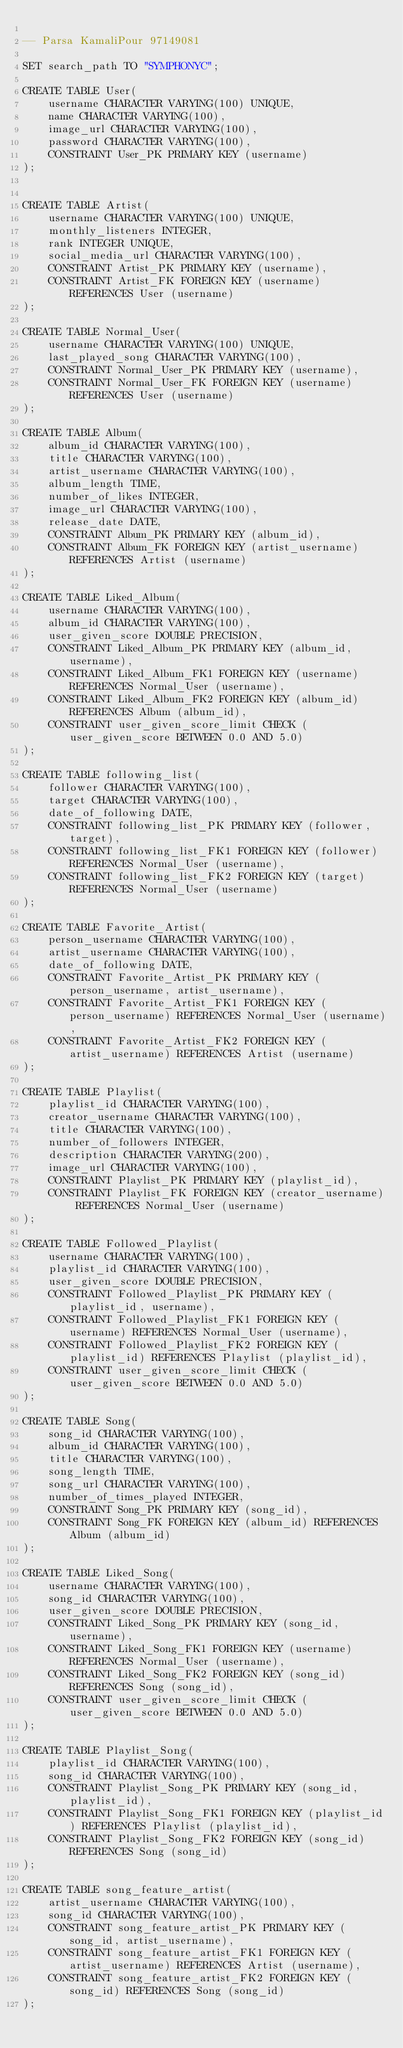<code> <loc_0><loc_0><loc_500><loc_500><_SQL_>
-- Parsa KamaliPour 97149081

SET search_path TO "SYMPHONYC";

CREATE TABLE User(
	username CHARACTER VARYING(100) UNIQUE,
	name CHARACTER VARYING(100),
	image_url CHARACTER VARYING(100),
	password CHARACTER VARYING(100),
	CONSTRAINT User_PK PRIMARY KEY (username)
);


CREATE TABLE Artist(
	username CHARACTER VARYING(100) UNIQUE,
	monthly_listeners INTEGER,
	rank INTEGER UNIQUE,
	social_media_url CHARACTER VARYING(100),
	CONSTRAINT Artist_PK PRIMARY KEY (username),
	CONSTRAINT Artist_FK FOREIGN KEY (username) REFERENCES User (username)
);

CREATE TABLE Normal_User(
	username CHARACTER VARYING(100) UNIQUE,
	last_played_song CHARACTER VARYING(100),
	CONSTRAINT Normal_User_PK PRIMARY KEY (username),
	CONSTRAINT Normal_User_FK FOREIGN KEY (username) REFERENCES User (username)
);

CREATE TABLE Album(
	album_id CHARACTER VARYING(100),
	title CHARACTER VARYING(100),
	artist_username CHARACTER VARYING(100),
	album_length TIME,
	number_of_likes INTEGER,
	image_url CHARACTER VARYING(100),
	release_date DATE,
	CONSTRAINT Album_PK PRIMARY KEY (album_id),
	CONSTRAINT Album_FK FOREIGN KEY (artist_username) REFERENCES Artist (username)
);

CREATE TABLE Liked_Album(
	username CHARACTER VARYING(100),
	album_id CHARACTER VARYING(100),
	user_given_score DOUBLE PRECISION,
	CONSTRAINT Liked_Album_PK PRIMARY KEY (album_id, username),
	CONSTRAINT Liked_Album_FK1 FOREIGN KEY (username) REFERENCES Normal_User (username),
	CONSTRAINT Liked_Album_FK2 FOREIGN KEY (album_id) REFERENCES Album (album_id),
	CONSTRAINT user_given_score_limit CHECK (user_given_score BETWEEN 0.0 AND 5.0)
);

CREATE TABLE following_list(
	follower CHARACTER VARYING(100),
	target CHARACTER VARYING(100),
	date_of_following DATE,
	CONSTRAINT following_list_PK PRIMARY KEY (follower, target),
	CONSTRAINT following_list_FK1 FOREIGN KEY (follower) REFERENCES Normal_User (username),
	CONSTRAINT following_list_FK2 FOREIGN KEY (target) REFERENCES Normal_User (username)
);

CREATE TABLE Favorite_Artist(
	person_username CHARACTER VARYING(100),
	artist_username CHARACTER VARYING(100),
	date_of_following DATE,
	CONSTRAINT Favorite_Artist_PK PRIMARY KEY (person_username, artist_username),
	CONSTRAINT Favorite_Artist_FK1 FOREIGN KEY (person_username) REFERENCES Normal_User (username),
	CONSTRAINT Favorite_Artist_FK2 FOREIGN KEY (artist_username) REFERENCES Artist (username)
);

CREATE TABLE Playlist(
	playlist_id CHARACTER VARYING(100),
	creator_username CHARACTER VARYING(100),
	title CHARACTER VARYING(100),
	number_of_followers INTEGER,
	description CHARACTER VARYING(200),
	image_url CHARACTER VARYING(100),
	CONSTRAINT Playlist_PK PRIMARY KEY (playlist_id),
	CONSTRAINT Playlist_FK FOREIGN KEY (creator_username) REFERENCES Normal_User (username)
);

CREATE TABLE Followed_Playlist(
	username CHARACTER VARYING(100),
	playlist_id CHARACTER VARYING(100),
	user_given_score DOUBLE PRECISION,
	CONSTRAINT Followed_Playlist_PK PRIMARY KEY (playlist_id, username),
	CONSTRAINT Followed_Playlist_FK1 FOREIGN KEY (username) REFERENCES Normal_User (username),
	CONSTRAINT Followed_Playlist_FK2 FOREIGN KEY (playlist_id) REFERENCES Playlist (playlist_id),
	CONSTRAINT user_given_score_limit CHECK (user_given_score BETWEEN 0.0 AND 5.0)
);

CREATE TABLE Song(
	song_id CHARACTER VARYING(100),
	album_id CHARACTER VARYING(100),
	title CHARACTER VARYING(100),
	song_length TIME,
	song_url CHARACTER VARYING(100),
	number_of_times_played INTEGER,
	CONSTRAINT Song_PK PRIMARY KEY (song_id),
	CONSTRAINT Song_FK FOREIGN KEY (album_id) REFERENCES Album (album_id)
);

CREATE TABLE Liked_Song(
	username CHARACTER VARYING(100),
	song_id CHARACTER VARYING(100),
	user_given_score DOUBLE PRECISION,
	CONSTRAINT Liked_Song_PK PRIMARY KEY (song_id, username),
	CONSTRAINT Liked_Song_FK1 FOREIGN KEY (username) REFERENCES Normal_User (username),
	CONSTRAINT Liked_Song_FK2 FOREIGN KEY (song_id) REFERENCES Song (song_id),
	CONSTRAINT user_given_score_limit CHECK (user_given_score BETWEEN 0.0 AND 5.0)
);

CREATE TABLE Playlist_Song(
	playlist_id CHARACTER VARYING(100),
	song_id CHARACTER VARYING(100),
	CONSTRAINT Playlist_Song_PK PRIMARY KEY (song_id, playlist_id),
	CONSTRAINT Playlist_Song_FK1 FOREIGN KEY (playlist_id) REFERENCES Playlist (playlist_id),
	CONSTRAINT Playlist_Song_FK2 FOREIGN KEY (song_id) REFERENCES Song (song_id)
);

CREATE TABLE song_feature_artist(
	artist_username CHARACTER VARYING(100),
	song_id CHARACTER VARYING(100),
	CONSTRAINT song_feature_artist_PK PRIMARY KEY (song_id, artist_username),
	CONSTRAINT song_feature_artist_FK1 FOREIGN KEY (artist_username) REFERENCES Artist (username),
	CONSTRAINT song_feature_artist_FK2 FOREIGN KEY (song_id) REFERENCES Song (song_id)
);

</code> 